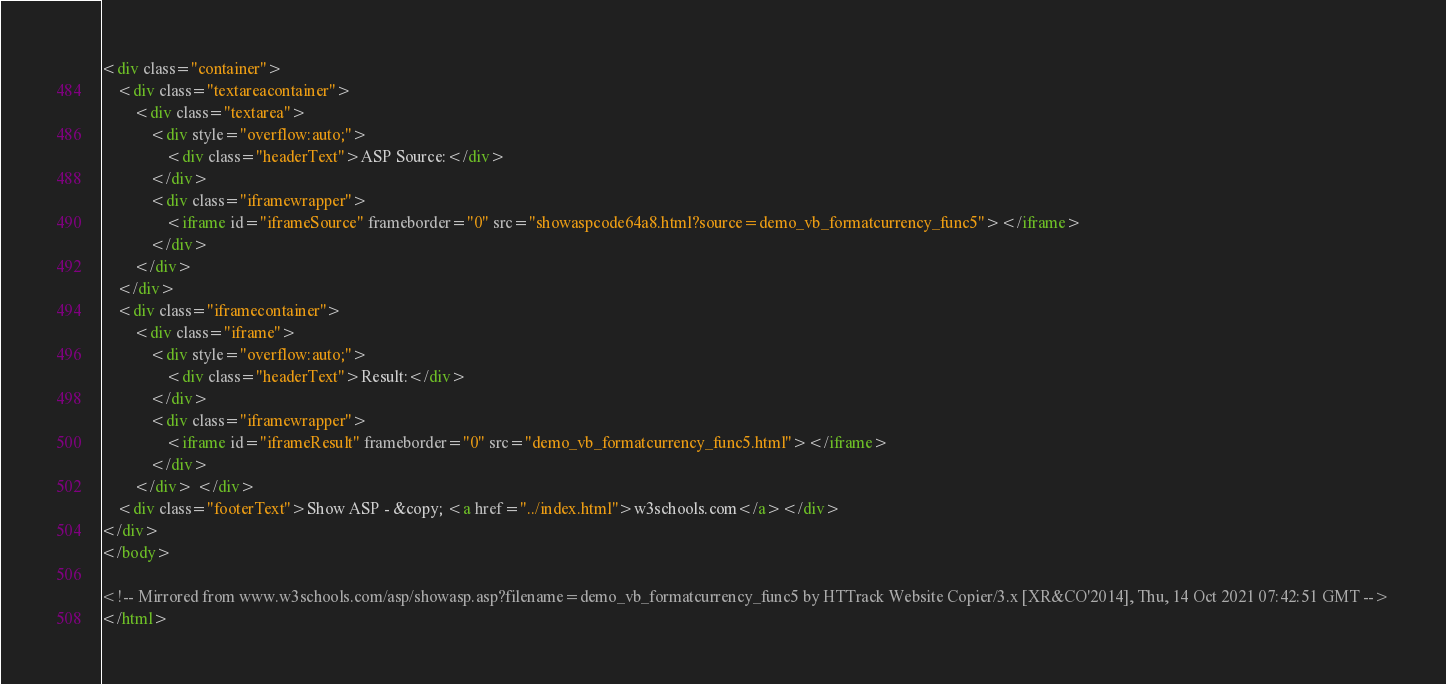<code> <loc_0><loc_0><loc_500><loc_500><_HTML_><div class="container">
	<div class="textareacontainer">
		<div class="textarea">
            <div style="overflow:auto;">
    			<div class="headerText">ASP Source:</div>
    		</div>
			<div class="iframewrapper">
				<iframe id="iframeSource" frameborder="0" src="showaspcode64a8.html?source=demo_vb_formatcurrency_func5"></iframe>
			</div>
		</div>
	</div>
	<div class="iframecontainer">
		<div class="iframe">
			<div style="overflow:auto;">
				<div class="headerText">Result:</div>
			</div>
			<div class="iframewrapper">
				<iframe id="iframeResult" frameborder="0" src="demo_vb_formatcurrency_func5.html"></iframe>
			</div>
		</div> </div>
    <div class="footerText">Show ASP - &copy; <a href="../index.html">w3schools.com</a></div>      
</div>
</body>

<!-- Mirrored from www.w3schools.com/asp/showasp.asp?filename=demo_vb_formatcurrency_func5 by HTTrack Website Copier/3.x [XR&CO'2014], Thu, 14 Oct 2021 07:42:51 GMT -->
</html></code> 